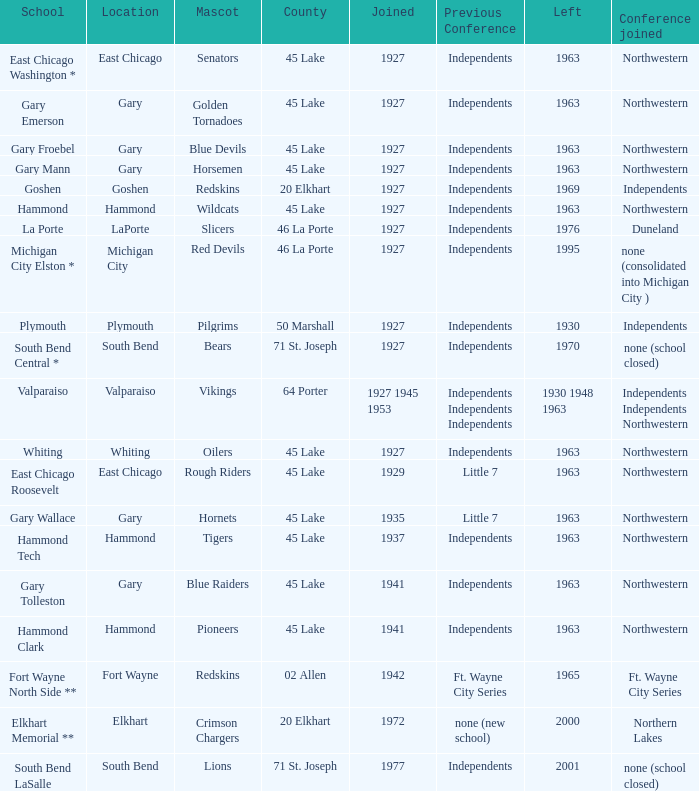When is the blue devils mascot present in gary froebel school? 1927.0. 